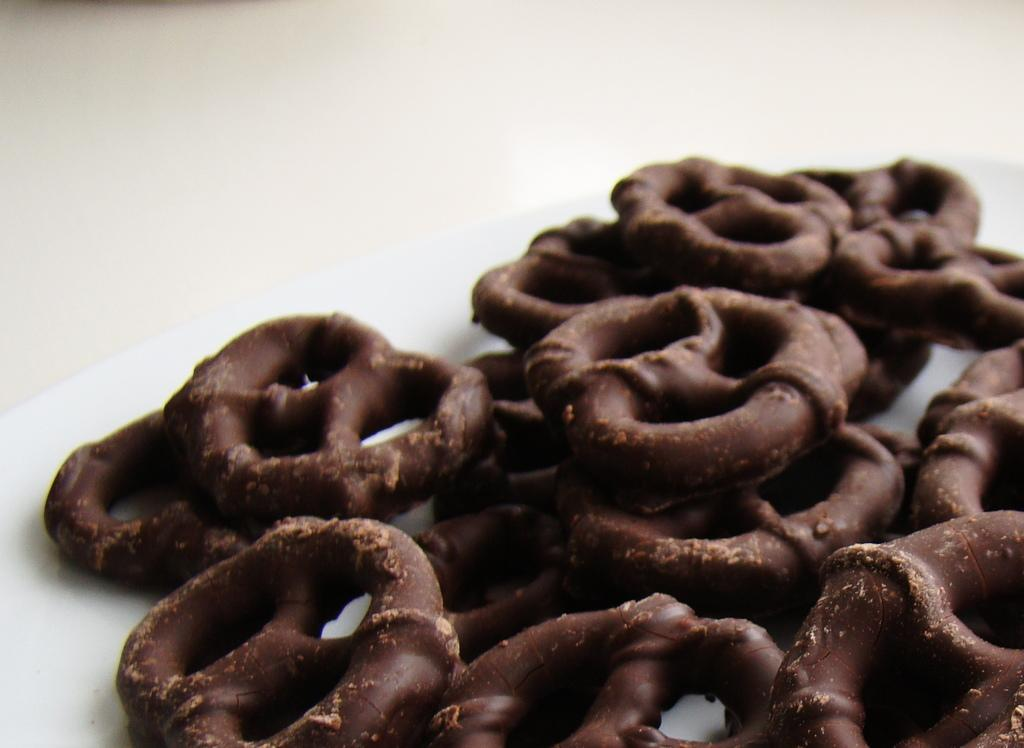What type of food can be seen in the image? There is baked food in the image. Where is the baked food placed? The baked food is placed on a surface. What type of twig is being used as a serving utensil for the baked food in the image? There is no twig present in the image, and it is not being used as a serving utensil. 